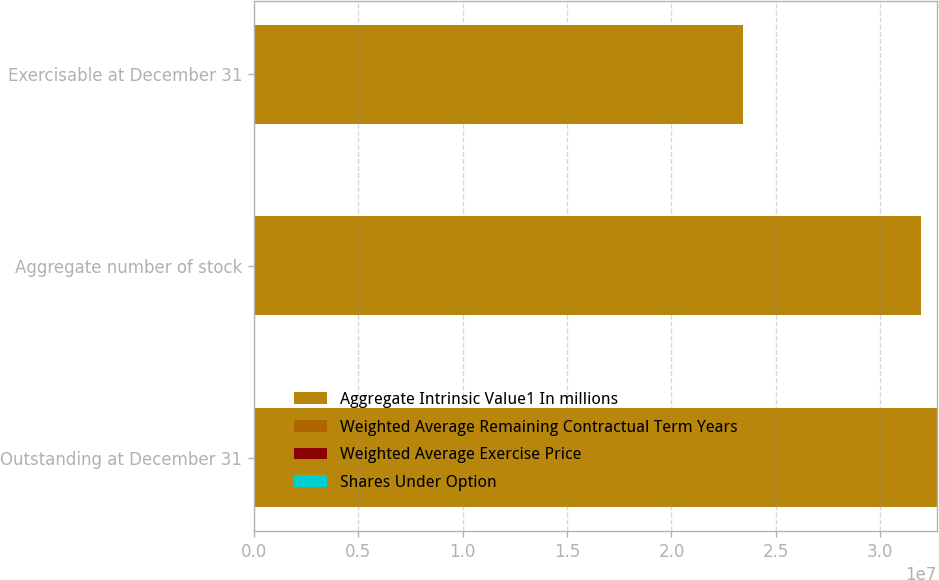Convert chart. <chart><loc_0><loc_0><loc_500><loc_500><stacked_bar_chart><ecel><fcel>Outstanding at December 31<fcel>Aggregate number of stock<fcel>Exercisable at December 31<nl><fcel>Aggregate Intrinsic Value1 In millions<fcel>3.27023e+07<fcel>3.1931e+07<fcel>2.3406e+07<nl><fcel>Weighted Average Remaining Contractual Term Years<fcel>38.47<fcel>38.62<fcel>40.43<nl><fcel>Weighted Average Exercise Price<fcel>5.3<fcel>5.21<fcel>4<nl><fcel>Shares Under Option<fcel>195<fcel>186<fcel>94<nl></chart> 